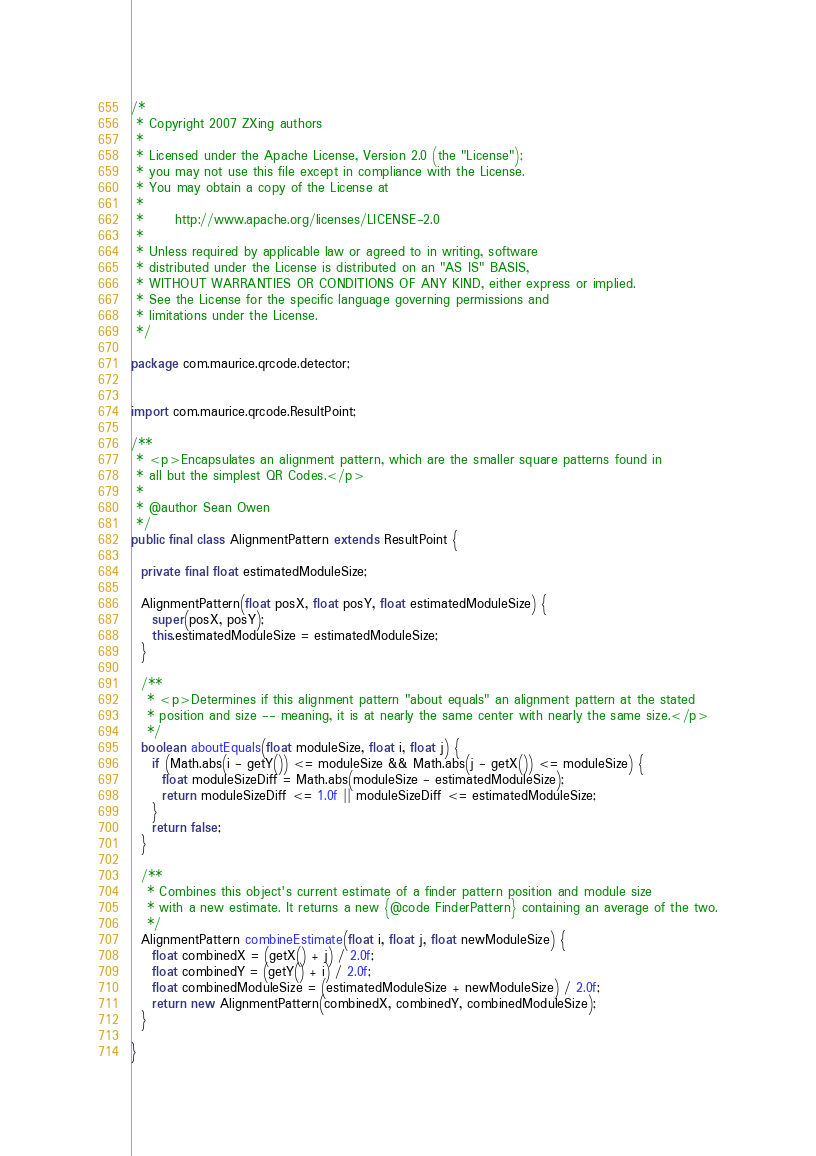Convert code to text. <code><loc_0><loc_0><loc_500><loc_500><_Java_>/*
 * Copyright 2007 ZXing authors
 *
 * Licensed under the Apache License, Version 2.0 (the "License");
 * you may not use this file except in compliance with the License.
 * You may obtain a copy of the License at
 *
 *      http://www.apache.org/licenses/LICENSE-2.0
 *
 * Unless required by applicable law or agreed to in writing, software
 * distributed under the License is distributed on an "AS IS" BASIS,
 * WITHOUT WARRANTIES OR CONDITIONS OF ANY KIND, either express or implied.
 * See the License for the specific language governing permissions and
 * limitations under the License.
 */

package com.maurice.qrcode.detector;


import com.maurice.qrcode.ResultPoint;

/**
 * <p>Encapsulates an alignment pattern, which are the smaller square patterns found in
 * all but the simplest QR Codes.</p>
 *
 * @author Sean Owen
 */
public final class AlignmentPattern extends ResultPoint {

  private final float estimatedModuleSize;

  AlignmentPattern(float posX, float posY, float estimatedModuleSize) {
    super(posX, posY);
    this.estimatedModuleSize = estimatedModuleSize;
  }

  /**
   * <p>Determines if this alignment pattern "about equals" an alignment pattern at the stated
   * position and size -- meaning, it is at nearly the same center with nearly the same size.</p>
   */
  boolean aboutEquals(float moduleSize, float i, float j) {
    if (Math.abs(i - getY()) <= moduleSize && Math.abs(j - getX()) <= moduleSize) {
      float moduleSizeDiff = Math.abs(moduleSize - estimatedModuleSize);
      return moduleSizeDiff <= 1.0f || moduleSizeDiff <= estimatedModuleSize;
    }
    return false;
  }

  /**
   * Combines this object's current estimate of a finder pattern position and module size
   * with a new estimate. It returns a new {@code FinderPattern} containing an average of the two.
   */
  AlignmentPattern combineEstimate(float i, float j, float newModuleSize) {
    float combinedX = (getX() + j) / 2.0f;
    float combinedY = (getY() + i) / 2.0f;
    float combinedModuleSize = (estimatedModuleSize + newModuleSize) / 2.0f;
    return new AlignmentPattern(combinedX, combinedY, combinedModuleSize);
  }

}</code> 